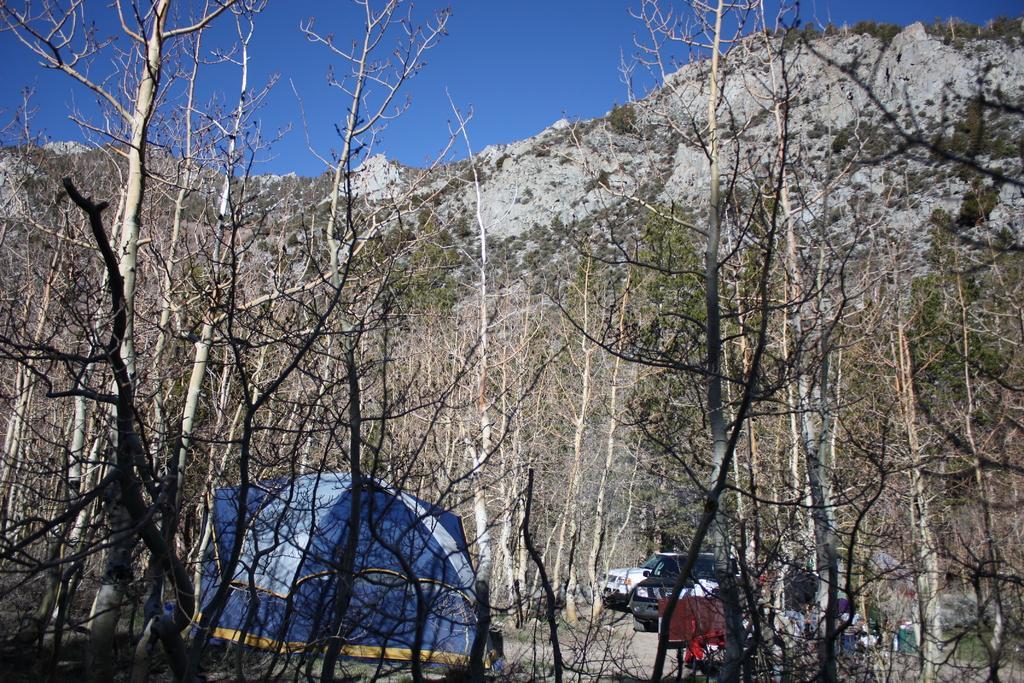How would you summarize this image in a sentence or two? In this image we can see there are some trees and mountains. In the middle of the trees there are some vehicles parked and a tent. In the background there is a sky. 